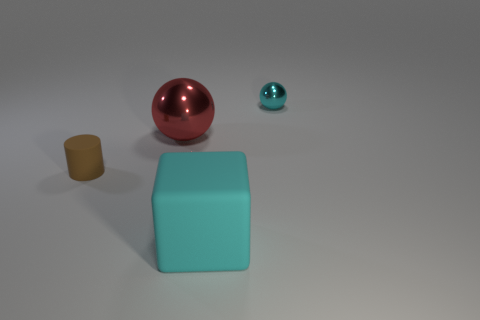Are there any other matte cubes that have the same color as the cube?
Your answer should be compact. No. How many small brown cylinders are on the right side of the large red thing?
Offer a terse response. 0. Is the material of the large cyan cube in front of the brown matte cylinder the same as the small thing that is in front of the big red metal object?
Your answer should be very brief. Yes. What is the color of the cylinder that is the same size as the cyan metallic object?
Give a very brief answer. Brown. Is there any other thing that has the same color as the big ball?
Ensure brevity in your answer.  No. What size is the thing behind the ball that is in front of the cyan thing that is behind the rubber block?
Your response must be concise. Small. What is the color of the object that is on the right side of the red shiny thing and left of the tiny cyan ball?
Keep it short and to the point. Cyan. What size is the object that is on the right side of the matte cube?
Your answer should be very brief. Small. What number of other big objects have the same material as the large red thing?
Offer a very short reply. 0. What shape is the tiny shiny object that is the same color as the big rubber cube?
Ensure brevity in your answer.  Sphere. 